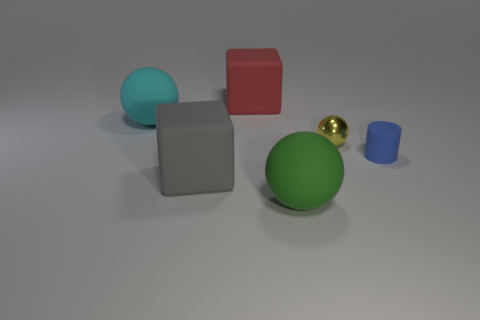Subtract all big rubber balls. How many balls are left? 1 Add 1 big spheres. How many objects exist? 7 Subtract all green balls. How many balls are left? 2 Subtract all cylinders. How many objects are left? 5 Subtract 1 cylinders. How many cylinders are left? 0 Add 4 big gray rubber cubes. How many big gray rubber cubes are left? 5 Add 4 large objects. How many large objects exist? 8 Subtract 0 gray spheres. How many objects are left? 6 Subtract all cyan cylinders. Subtract all blue balls. How many cylinders are left? 1 Subtract all big gray blocks. Subtract all big green rubber balls. How many objects are left? 4 